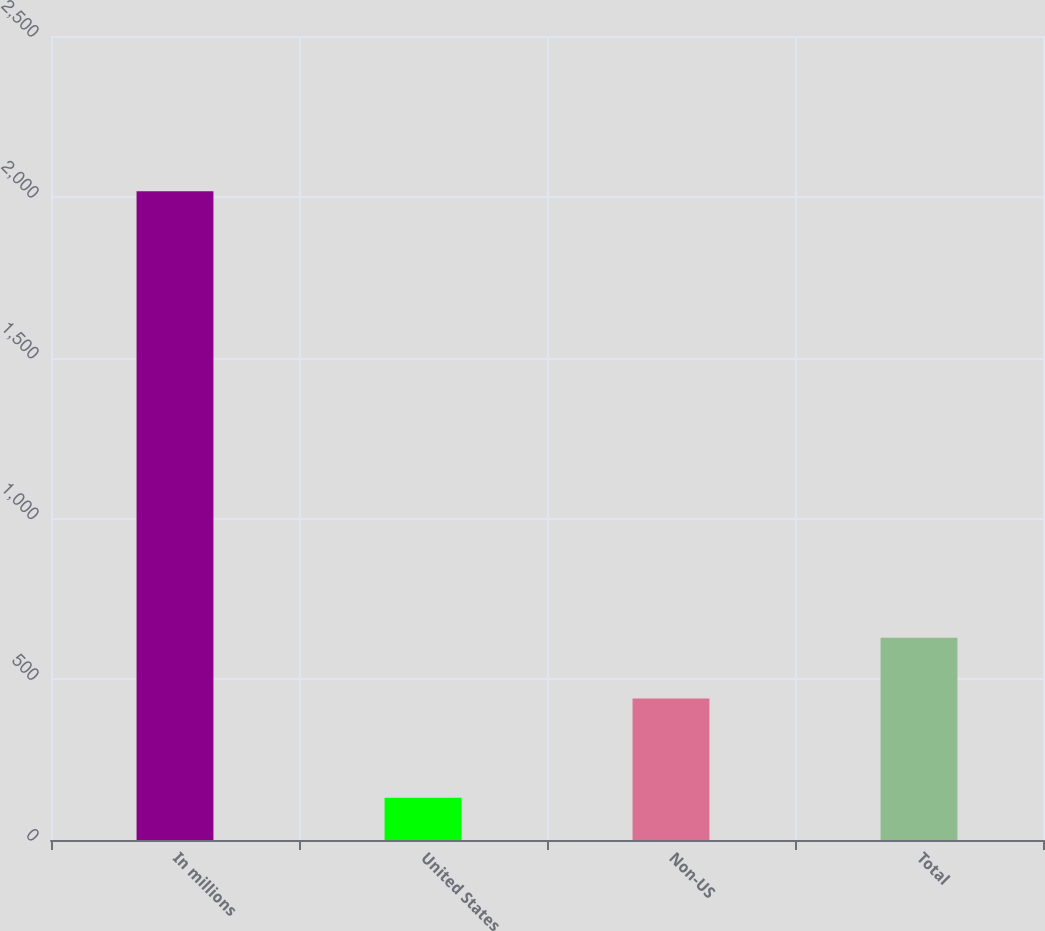Convert chart. <chart><loc_0><loc_0><loc_500><loc_500><bar_chart><fcel>In millions<fcel>United States<fcel>Non-US<fcel>Total<nl><fcel>2017<fcel>131<fcel>440.1<fcel>628.7<nl></chart> 